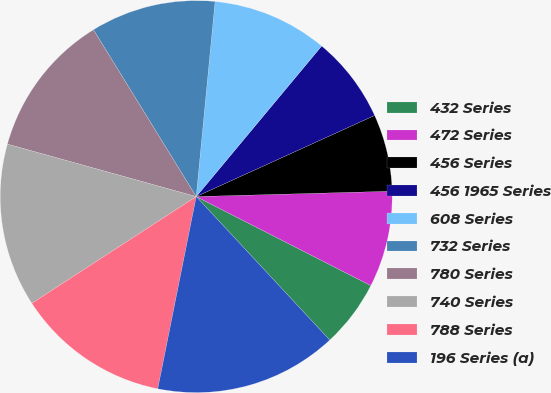Convert chart. <chart><loc_0><loc_0><loc_500><loc_500><pie_chart><fcel>432 Series<fcel>472 Series<fcel>456 Series<fcel>456 1965 Series<fcel>608 Series<fcel>732 Series<fcel>780 Series<fcel>740 Series<fcel>788 Series<fcel>196 Series (a)<nl><fcel>5.57%<fcel>7.94%<fcel>6.36%<fcel>7.15%<fcel>9.52%<fcel>10.32%<fcel>11.9%<fcel>13.48%<fcel>12.69%<fcel>15.07%<nl></chart> 